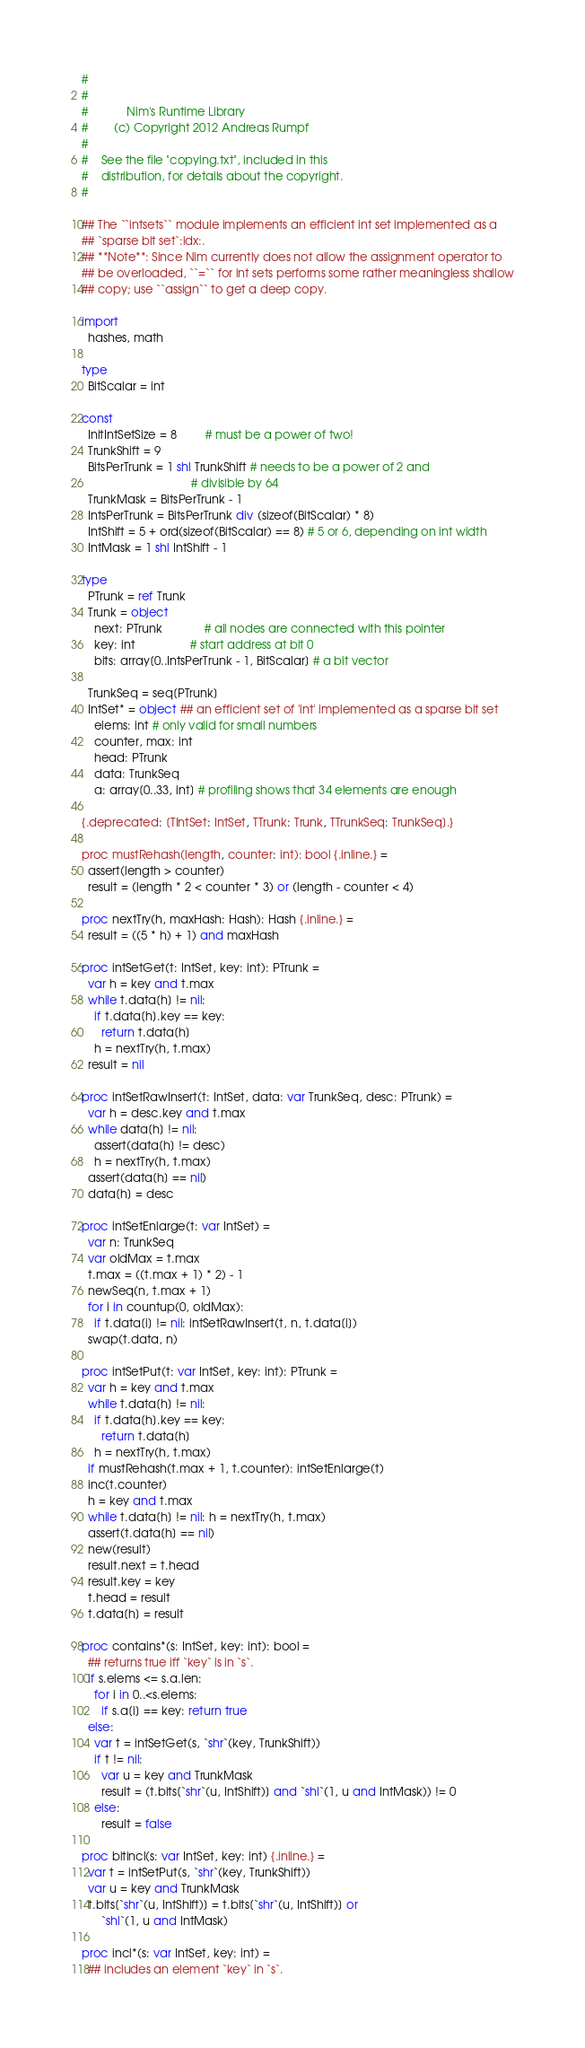Convert code to text. <code><loc_0><loc_0><loc_500><loc_500><_Nim_>#
#
#            Nim's Runtime Library
#        (c) Copyright 2012 Andreas Rumpf
#
#    See the file "copying.txt", included in this
#    distribution, for details about the copyright.
#

## The ``intsets`` module implements an efficient int set implemented as a
## `sparse bit set`:idx:.
## **Note**: Since Nim currently does not allow the assignment operator to
## be overloaded, ``=`` for int sets performs some rather meaningless shallow
## copy; use ``assign`` to get a deep copy.

import
  hashes, math

type
  BitScalar = int

const
  InitIntSetSize = 8         # must be a power of two!
  TrunkShift = 9
  BitsPerTrunk = 1 shl TrunkShift # needs to be a power of 2 and
                                  # divisible by 64
  TrunkMask = BitsPerTrunk - 1
  IntsPerTrunk = BitsPerTrunk div (sizeof(BitScalar) * 8)
  IntShift = 5 + ord(sizeof(BitScalar) == 8) # 5 or 6, depending on int width
  IntMask = 1 shl IntShift - 1

type
  PTrunk = ref Trunk
  Trunk = object
    next: PTrunk             # all nodes are connected with this pointer
    key: int                 # start address at bit 0
    bits: array[0..IntsPerTrunk - 1, BitScalar] # a bit vector

  TrunkSeq = seq[PTrunk]
  IntSet* = object ## an efficient set of 'int' implemented as a sparse bit set
    elems: int # only valid for small numbers
    counter, max: int
    head: PTrunk
    data: TrunkSeq
    a: array[0..33, int] # profiling shows that 34 elements are enough

{.deprecated: [TIntSet: IntSet, TTrunk: Trunk, TTrunkSeq: TrunkSeq].}

proc mustRehash(length, counter: int): bool {.inline.} =
  assert(length > counter)
  result = (length * 2 < counter * 3) or (length - counter < 4)

proc nextTry(h, maxHash: Hash): Hash {.inline.} =
  result = ((5 * h) + 1) and maxHash

proc intSetGet(t: IntSet, key: int): PTrunk =
  var h = key and t.max
  while t.data[h] != nil:
    if t.data[h].key == key:
      return t.data[h]
    h = nextTry(h, t.max)
  result = nil

proc intSetRawInsert(t: IntSet, data: var TrunkSeq, desc: PTrunk) =
  var h = desc.key and t.max
  while data[h] != nil:
    assert(data[h] != desc)
    h = nextTry(h, t.max)
  assert(data[h] == nil)
  data[h] = desc

proc intSetEnlarge(t: var IntSet) =
  var n: TrunkSeq
  var oldMax = t.max
  t.max = ((t.max + 1) * 2) - 1
  newSeq(n, t.max + 1)
  for i in countup(0, oldMax):
    if t.data[i] != nil: intSetRawInsert(t, n, t.data[i])
  swap(t.data, n)

proc intSetPut(t: var IntSet, key: int): PTrunk =
  var h = key and t.max
  while t.data[h] != nil:
    if t.data[h].key == key:
      return t.data[h]
    h = nextTry(h, t.max)
  if mustRehash(t.max + 1, t.counter): intSetEnlarge(t)
  inc(t.counter)
  h = key and t.max
  while t.data[h] != nil: h = nextTry(h, t.max)
  assert(t.data[h] == nil)
  new(result)
  result.next = t.head
  result.key = key
  t.head = result
  t.data[h] = result

proc contains*(s: IntSet, key: int): bool =
  ## returns true iff `key` is in `s`.
  if s.elems <= s.a.len:
    for i in 0..<s.elems:
      if s.a[i] == key: return true
  else:
    var t = intSetGet(s, `shr`(key, TrunkShift))
    if t != nil:
      var u = key and TrunkMask
      result = (t.bits[`shr`(u, IntShift)] and `shl`(1, u and IntMask)) != 0
    else:
      result = false

proc bitincl(s: var IntSet, key: int) {.inline.} =
  var t = intSetPut(s, `shr`(key, TrunkShift))
  var u = key and TrunkMask
  t.bits[`shr`(u, IntShift)] = t.bits[`shr`(u, IntShift)] or
      `shl`(1, u and IntMask)

proc incl*(s: var IntSet, key: int) =
  ## includes an element `key` in `s`.</code> 